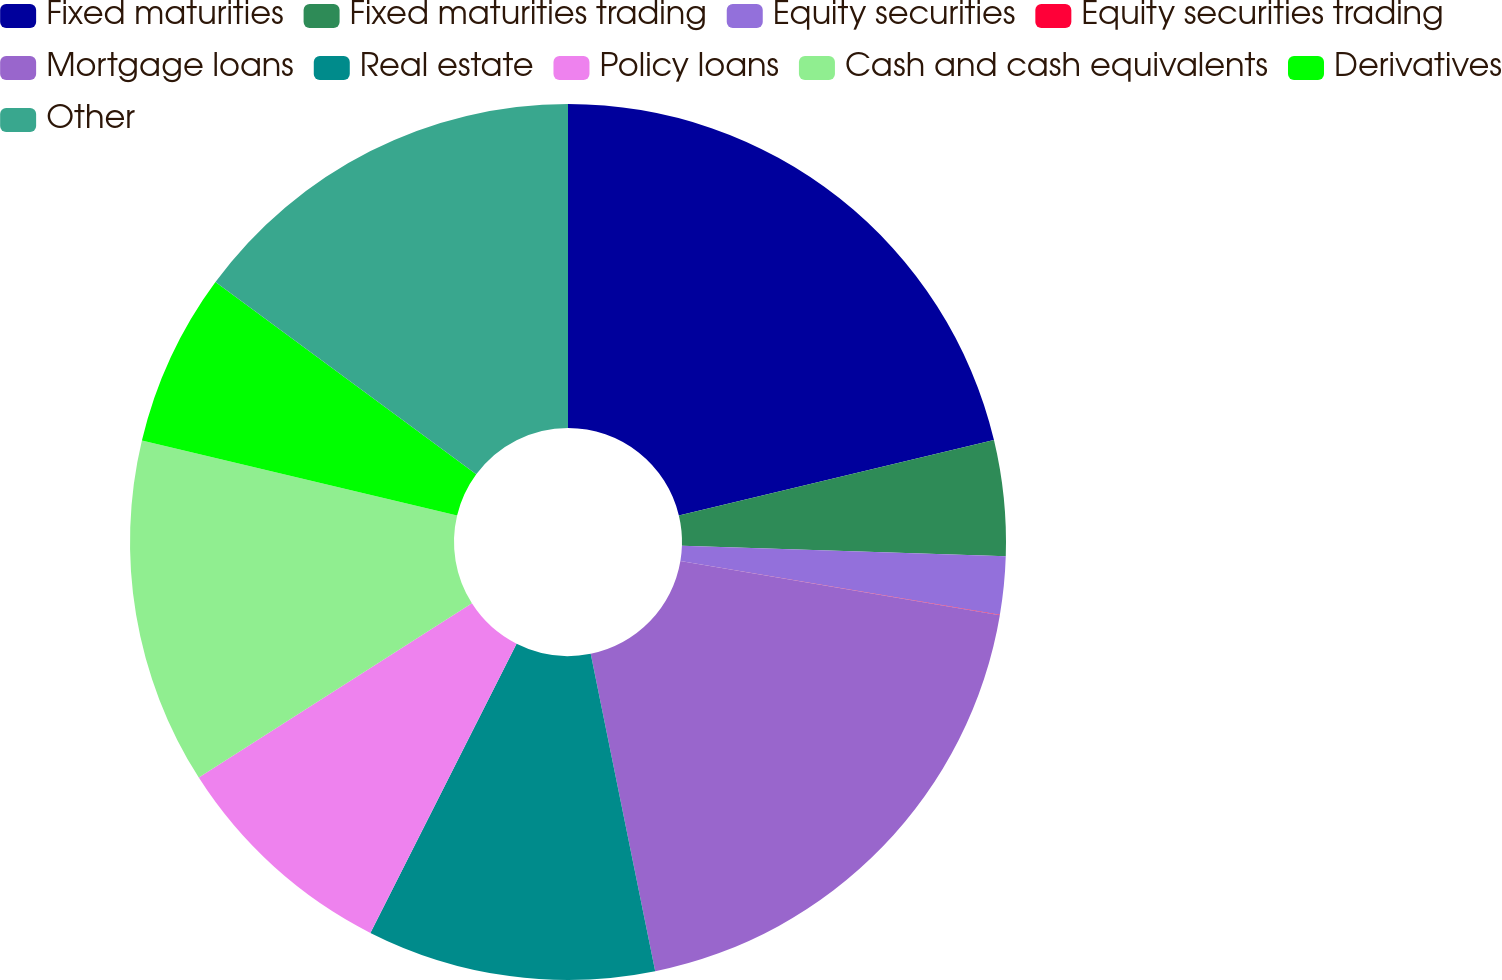<chart> <loc_0><loc_0><loc_500><loc_500><pie_chart><fcel>Fixed maturities<fcel>Fixed maturities trading<fcel>Equity securities<fcel>Equity securities trading<fcel>Mortgage loans<fcel>Real estate<fcel>Policy loans<fcel>Cash and cash equivalents<fcel>Derivatives<fcel>Other<nl><fcel>21.26%<fcel>4.26%<fcel>2.14%<fcel>0.01%<fcel>19.14%<fcel>10.64%<fcel>8.51%<fcel>12.76%<fcel>6.39%<fcel>14.89%<nl></chart> 